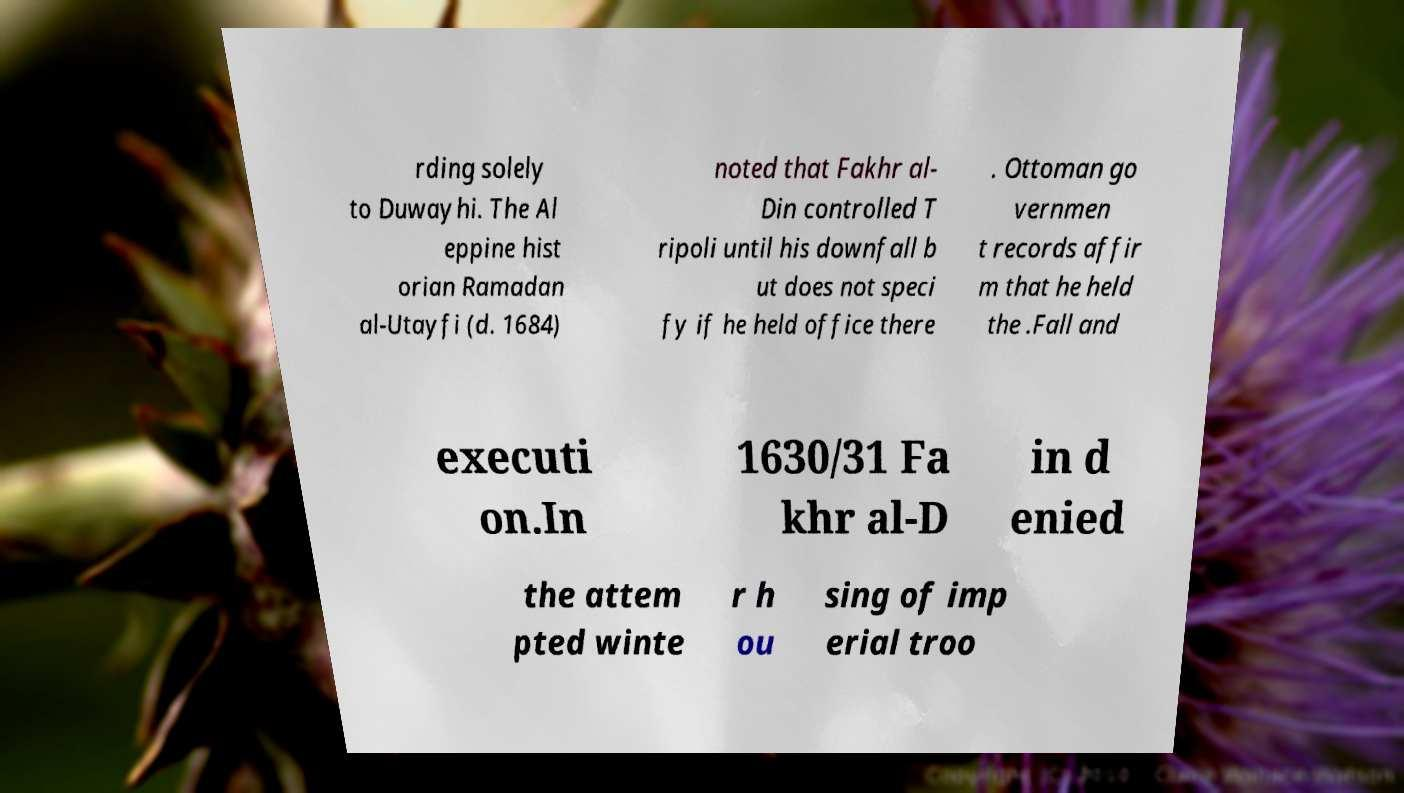Please read and relay the text visible in this image. What does it say? rding solely to Duwayhi. The Al eppine hist orian Ramadan al-Utayfi (d. 1684) noted that Fakhr al- Din controlled T ripoli until his downfall b ut does not speci fy if he held office there . Ottoman go vernmen t records affir m that he held the .Fall and executi on.In 1630/31 Fa khr al-D in d enied the attem pted winte r h ou sing of imp erial troo 